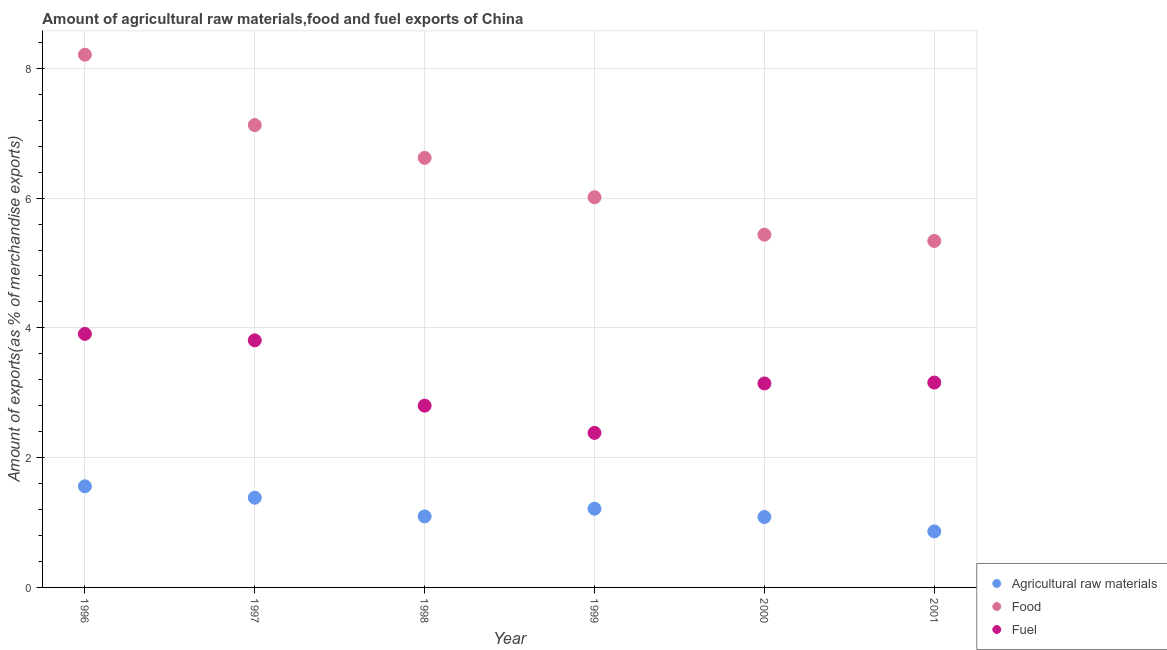What is the percentage of food exports in 2001?
Ensure brevity in your answer.  5.34. Across all years, what is the maximum percentage of fuel exports?
Ensure brevity in your answer.  3.91. Across all years, what is the minimum percentage of fuel exports?
Keep it short and to the point. 2.38. In which year was the percentage of food exports maximum?
Make the answer very short. 1996. In which year was the percentage of raw materials exports minimum?
Provide a succinct answer. 2001. What is the total percentage of fuel exports in the graph?
Give a very brief answer. 19.2. What is the difference between the percentage of food exports in 1997 and that in 2000?
Make the answer very short. 1.69. What is the difference between the percentage of raw materials exports in 1997 and the percentage of food exports in 1998?
Ensure brevity in your answer.  -5.24. What is the average percentage of fuel exports per year?
Your answer should be very brief. 3.2. In the year 1997, what is the difference between the percentage of raw materials exports and percentage of food exports?
Provide a short and direct response. -5.74. In how many years, is the percentage of food exports greater than 3.6 %?
Your answer should be very brief. 6. What is the ratio of the percentage of fuel exports in 1998 to that in 1999?
Offer a very short reply. 1.18. Is the percentage of food exports in 1997 less than that in 1998?
Provide a short and direct response. No. What is the difference between the highest and the second highest percentage of food exports?
Your answer should be compact. 1.09. What is the difference between the highest and the lowest percentage of food exports?
Ensure brevity in your answer.  2.87. In how many years, is the percentage of raw materials exports greater than the average percentage of raw materials exports taken over all years?
Give a very brief answer. 3. Is the percentage of raw materials exports strictly greater than the percentage of fuel exports over the years?
Make the answer very short. No. How many dotlines are there?
Offer a terse response. 3. What is the difference between two consecutive major ticks on the Y-axis?
Ensure brevity in your answer.  2. Does the graph contain grids?
Keep it short and to the point. Yes. Where does the legend appear in the graph?
Give a very brief answer. Bottom right. What is the title of the graph?
Make the answer very short. Amount of agricultural raw materials,food and fuel exports of China. What is the label or title of the X-axis?
Keep it short and to the point. Year. What is the label or title of the Y-axis?
Your response must be concise. Amount of exports(as % of merchandise exports). What is the Amount of exports(as % of merchandise exports) in Agricultural raw materials in 1996?
Give a very brief answer. 1.56. What is the Amount of exports(as % of merchandise exports) of Food in 1996?
Provide a succinct answer. 8.21. What is the Amount of exports(as % of merchandise exports) of Fuel in 1996?
Offer a terse response. 3.91. What is the Amount of exports(as % of merchandise exports) in Agricultural raw materials in 1997?
Provide a succinct answer. 1.38. What is the Amount of exports(as % of merchandise exports) of Food in 1997?
Give a very brief answer. 7.13. What is the Amount of exports(as % of merchandise exports) of Fuel in 1997?
Your response must be concise. 3.81. What is the Amount of exports(as % of merchandise exports) in Agricultural raw materials in 1998?
Make the answer very short. 1.09. What is the Amount of exports(as % of merchandise exports) in Food in 1998?
Offer a very short reply. 6.62. What is the Amount of exports(as % of merchandise exports) in Fuel in 1998?
Provide a short and direct response. 2.8. What is the Amount of exports(as % of merchandise exports) in Agricultural raw materials in 1999?
Make the answer very short. 1.21. What is the Amount of exports(as % of merchandise exports) in Food in 1999?
Give a very brief answer. 6.01. What is the Amount of exports(as % of merchandise exports) in Fuel in 1999?
Offer a very short reply. 2.38. What is the Amount of exports(as % of merchandise exports) of Agricultural raw materials in 2000?
Provide a succinct answer. 1.09. What is the Amount of exports(as % of merchandise exports) in Food in 2000?
Give a very brief answer. 5.44. What is the Amount of exports(as % of merchandise exports) of Fuel in 2000?
Provide a succinct answer. 3.14. What is the Amount of exports(as % of merchandise exports) in Agricultural raw materials in 2001?
Your answer should be compact. 0.86. What is the Amount of exports(as % of merchandise exports) in Food in 2001?
Your response must be concise. 5.34. What is the Amount of exports(as % of merchandise exports) in Fuel in 2001?
Make the answer very short. 3.16. Across all years, what is the maximum Amount of exports(as % of merchandise exports) of Agricultural raw materials?
Your answer should be very brief. 1.56. Across all years, what is the maximum Amount of exports(as % of merchandise exports) of Food?
Make the answer very short. 8.21. Across all years, what is the maximum Amount of exports(as % of merchandise exports) of Fuel?
Provide a short and direct response. 3.91. Across all years, what is the minimum Amount of exports(as % of merchandise exports) in Agricultural raw materials?
Ensure brevity in your answer.  0.86. Across all years, what is the minimum Amount of exports(as % of merchandise exports) in Food?
Provide a short and direct response. 5.34. Across all years, what is the minimum Amount of exports(as % of merchandise exports) of Fuel?
Keep it short and to the point. 2.38. What is the total Amount of exports(as % of merchandise exports) of Agricultural raw materials in the graph?
Offer a terse response. 7.2. What is the total Amount of exports(as % of merchandise exports) in Food in the graph?
Make the answer very short. 38.75. What is the total Amount of exports(as % of merchandise exports) of Fuel in the graph?
Give a very brief answer. 19.2. What is the difference between the Amount of exports(as % of merchandise exports) in Agricultural raw materials in 1996 and that in 1997?
Provide a succinct answer. 0.18. What is the difference between the Amount of exports(as % of merchandise exports) of Food in 1996 and that in 1997?
Your response must be concise. 1.09. What is the difference between the Amount of exports(as % of merchandise exports) in Fuel in 1996 and that in 1997?
Your answer should be very brief. 0.1. What is the difference between the Amount of exports(as % of merchandise exports) in Agricultural raw materials in 1996 and that in 1998?
Your answer should be compact. 0.46. What is the difference between the Amount of exports(as % of merchandise exports) of Food in 1996 and that in 1998?
Offer a very short reply. 1.59. What is the difference between the Amount of exports(as % of merchandise exports) of Fuel in 1996 and that in 1998?
Provide a short and direct response. 1.11. What is the difference between the Amount of exports(as % of merchandise exports) of Agricultural raw materials in 1996 and that in 1999?
Your response must be concise. 0.35. What is the difference between the Amount of exports(as % of merchandise exports) of Food in 1996 and that in 1999?
Your answer should be very brief. 2.2. What is the difference between the Amount of exports(as % of merchandise exports) in Fuel in 1996 and that in 1999?
Give a very brief answer. 1.53. What is the difference between the Amount of exports(as % of merchandise exports) in Agricultural raw materials in 1996 and that in 2000?
Offer a terse response. 0.47. What is the difference between the Amount of exports(as % of merchandise exports) in Food in 1996 and that in 2000?
Provide a short and direct response. 2.77. What is the difference between the Amount of exports(as % of merchandise exports) in Fuel in 1996 and that in 2000?
Make the answer very short. 0.76. What is the difference between the Amount of exports(as % of merchandise exports) of Agricultural raw materials in 1996 and that in 2001?
Keep it short and to the point. 0.69. What is the difference between the Amount of exports(as % of merchandise exports) of Food in 1996 and that in 2001?
Your answer should be compact. 2.87. What is the difference between the Amount of exports(as % of merchandise exports) of Fuel in 1996 and that in 2001?
Ensure brevity in your answer.  0.75. What is the difference between the Amount of exports(as % of merchandise exports) of Agricultural raw materials in 1997 and that in 1998?
Offer a terse response. 0.29. What is the difference between the Amount of exports(as % of merchandise exports) in Food in 1997 and that in 1998?
Give a very brief answer. 0.51. What is the difference between the Amount of exports(as % of merchandise exports) of Fuel in 1997 and that in 1998?
Ensure brevity in your answer.  1.01. What is the difference between the Amount of exports(as % of merchandise exports) in Agricultural raw materials in 1997 and that in 1999?
Offer a very short reply. 0.17. What is the difference between the Amount of exports(as % of merchandise exports) of Food in 1997 and that in 1999?
Keep it short and to the point. 1.11. What is the difference between the Amount of exports(as % of merchandise exports) of Fuel in 1997 and that in 1999?
Your answer should be very brief. 1.43. What is the difference between the Amount of exports(as % of merchandise exports) of Agricultural raw materials in 1997 and that in 2000?
Offer a very short reply. 0.3. What is the difference between the Amount of exports(as % of merchandise exports) in Food in 1997 and that in 2000?
Give a very brief answer. 1.69. What is the difference between the Amount of exports(as % of merchandise exports) in Fuel in 1997 and that in 2000?
Offer a terse response. 0.66. What is the difference between the Amount of exports(as % of merchandise exports) in Agricultural raw materials in 1997 and that in 2001?
Offer a very short reply. 0.52. What is the difference between the Amount of exports(as % of merchandise exports) in Food in 1997 and that in 2001?
Provide a succinct answer. 1.79. What is the difference between the Amount of exports(as % of merchandise exports) of Fuel in 1997 and that in 2001?
Provide a short and direct response. 0.65. What is the difference between the Amount of exports(as % of merchandise exports) of Agricultural raw materials in 1998 and that in 1999?
Offer a terse response. -0.12. What is the difference between the Amount of exports(as % of merchandise exports) of Food in 1998 and that in 1999?
Your answer should be compact. 0.61. What is the difference between the Amount of exports(as % of merchandise exports) of Fuel in 1998 and that in 1999?
Offer a terse response. 0.42. What is the difference between the Amount of exports(as % of merchandise exports) of Agricultural raw materials in 1998 and that in 2000?
Your response must be concise. 0.01. What is the difference between the Amount of exports(as % of merchandise exports) of Food in 1998 and that in 2000?
Your answer should be very brief. 1.18. What is the difference between the Amount of exports(as % of merchandise exports) of Fuel in 1998 and that in 2000?
Offer a very short reply. -0.34. What is the difference between the Amount of exports(as % of merchandise exports) in Agricultural raw materials in 1998 and that in 2001?
Make the answer very short. 0.23. What is the difference between the Amount of exports(as % of merchandise exports) in Food in 1998 and that in 2001?
Make the answer very short. 1.28. What is the difference between the Amount of exports(as % of merchandise exports) in Fuel in 1998 and that in 2001?
Ensure brevity in your answer.  -0.36. What is the difference between the Amount of exports(as % of merchandise exports) of Agricultural raw materials in 1999 and that in 2000?
Your response must be concise. 0.13. What is the difference between the Amount of exports(as % of merchandise exports) of Food in 1999 and that in 2000?
Your answer should be very brief. 0.58. What is the difference between the Amount of exports(as % of merchandise exports) of Fuel in 1999 and that in 2000?
Your response must be concise. -0.76. What is the difference between the Amount of exports(as % of merchandise exports) of Agricultural raw materials in 1999 and that in 2001?
Give a very brief answer. 0.35. What is the difference between the Amount of exports(as % of merchandise exports) in Food in 1999 and that in 2001?
Provide a short and direct response. 0.67. What is the difference between the Amount of exports(as % of merchandise exports) of Fuel in 1999 and that in 2001?
Your answer should be compact. -0.78. What is the difference between the Amount of exports(as % of merchandise exports) in Agricultural raw materials in 2000 and that in 2001?
Ensure brevity in your answer.  0.22. What is the difference between the Amount of exports(as % of merchandise exports) of Food in 2000 and that in 2001?
Ensure brevity in your answer.  0.1. What is the difference between the Amount of exports(as % of merchandise exports) in Fuel in 2000 and that in 2001?
Your answer should be very brief. -0.01. What is the difference between the Amount of exports(as % of merchandise exports) of Agricultural raw materials in 1996 and the Amount of exports(as % of merchandise exports) of Food in 1997?
Offer a terse response. -5.57. What is the difference between the Amount of exports(as % of merchandise exports) of Agricultural raw materials in 1996 and the Amount of exports(as % of merchandise exports) of Fuel in 1997?
Offer a very short reply. -2.25. What is the difference between the Amount of exports(as % of merchandise exports) in Food in 1996 and the Amount of exports(as % of merchandise exports) in Fuel in 1997?
Your response must be concise. 4.4. What is the difference between the Amount of exports(as % of merchandise exports) in Agricultural raw materials in 1996 and the Amount of exports(as % of merchandise exports) in Food in 1998?
Your answer should be very brief. -5.06. What is the difference between the Amount of exports(as % of merchandise exports) of Agricultural raw materials in 1996 and the Amount of exports(as % of merchandise exports) of Fuel in 1998?
Keep it short and to the point. -1.24. What is the difference between the Amount of exports(as % of merchandise exports) in Food in 1996 and the Amount of exports(as % of merchandise exports) in Fuel in 1998?
Ensure brevity in your answer.  5.41. What is the difference between the Amount of exports(as % of merchandise exports) in Agricultural raw materials in 1996 and the Amount of exports(as % of merchandise exports) in Food in 1999?
Your response must be concise. -4.46. What is the difference between the Amount of exports(as % of merchandise exports) of Agricultural raw materials in 1996 and the Amount of exports(as % of merchandise exports) of Fuel in 1999?
Keep it short and to the point. -0.82. What is the difference between the Amount of exports(as % of merchandise exports) in Food in 1996 and the Amount of exports(as % of merchandise exports) in Fuel in 1999?
Offer a terse response. 5.83. What is the difference between the Amount of exports(as % of merchandise exports) of Agricultural raw materials in 1996 and the Amount of exports(as % of merchandise exports) of Food in 2000?
Your response must be concise. -3.88. What is the difference between the Amount of exports(as % of merchandise exports) in Agricultural raw materials in 1996 and the Amount of exports(as % of merchandise exports) in Fuel in 2000?
Make the answer very short. -1.58. What is the difference between the Amount of exports(as % of merchandise exports) of Food in 1996 and the Amount of exports(as % of merchandise exports) of Fuel in 2000?
Ensure brevity in your answer.  5.07. What is the difference between the Amount of exports(as % of merchandise exports) of Agricultural raw materials in 1996 and the Amount of exports(as % of merchandise exports) of Food in 2001?
Make the answer very short. -3.78. What is the difference between the Amount of exports(as % of merchandise exports) of Agricultural raw materials in 1996 and the Amount of exports(as % of merchandise exports) of Fuel in 2001?
Ensure brevity in your answer.  -1.6. What is the difference between the Amount of exports(as % of merchandise exports) in Food in 1996 and the Amount of exports(as % of merchandise exports) in Fuel in 2001?
Give a very brief answer. 5.05. What is the difference between the Amount of exports(as % of merchandise exports) of Agricultural raw materials in 1997 and the Amount of exports(as % of merchandise exports) of Food in 1998?
Keep it short and to the point. -5.24. What is the difference between the Amount of exports(as % of merchandise exports) of Agricultural raw materials in 1997 and the Amount of exports(as % of merchandise exports) of Fuel in 1998?
Your answer should be very brief. -1.42. What is the difference between the Amount of exports(as % of merchandise exports) in Food in 1997 and the Amount of exports(as % of merchandise exports) in Fuel in 1998?
Ensure brevity in your answer.  4.32. What is the difference between the Amount of exports(as % of merchandise exports) in Agricultural raw materials in 1997 and the Amount of exports(as % of merchandise exports) in Food in 1999?
Your answer should be compact. -4.63. What is the difference between the Amount of exports(as % of merchandise exports) in Agricultural raw materials in 1997 and the Amount of exports(as % of merchandise exports) in Fuel in 1999?
Offer a terse response. -1. What is the difference between the Amount of exports(as % of merchandise exports) in Food in 1997 and the Amount of exports(as % of merchandise exports) in Fuel in 1999?
Offer a terse response. 4.74. What is the difference between the Amount of exports(as % of merchandise exports) in Agricultural raw materials in 1997 and the Amount of exports(as % of merchandise exports) in Food in 2000?
Keep it short and to the point. -4.05. What is the difference between the Amount of exports(as % of merchandise exports) in Agricultural raw materials in 1997 and the Amount of exports(as % of merchandise exports) in Fuel in 2000?
Offer a terse response. -1.76. What is the difference between the Amount of exports(as % of merchandise exports) in Food in 1997 and the Amount of exports(as % of merchandise exports) in Fuel in 2000?
Keep it short and to the point. 3.98. What is the difference between the Amount of exports(as % of merchandise exports) of Agricultural raw materials in 1997 and the Amount of exports(as % of merchandise exports) of Food in 2001?
Make the answer very short. -3.96. What is the difference between the Amount of exports(as % of merchandise exports) in Agricultural raw materials in 1997 and the Amount of exports(as % of merchandise exports) in Fuel in 2001?
Ensure brevity in your answer.  -1.77. What is the difference between the Amount of exports(as % of merchandise exports) of Food in 1997 and the Amount of exports(as % of merchandise exports) of Fuel in 2001?
Provide a short and direct response. 3.97. What is the difference between the Amount of exports(as % of merchandise exports) of Agricultural raw materials in 1998 and the Amount of exports(as % of merchandise exports) of Food in 1999?
Provide a short and direct response. -4.92. What is the difference between the Amount of exports(as % of merchandise exports) in Agricultural raw materials in 1998 and the Amount of exports(as % of merchandise exports) in Fuel in 1999?
Your response must be concise. -1.29. What is the difference between the Amount of exports(as % of merchandise exports) in Food in 1998 and the Amount of exports(as % of merchandise exports) in Fuel in 1999?
Ensure brevity in your answer.  4.24. What is the difference between the Amount of exports(as % of merchandise exports) in Agricultural raw materials in 1998 and the Amount of exports(as % of merchandise exports) in Food in 2000?
Your answer should be compact. -4.34. What is the difference between the Amount of exports(as % of merchandise exports) of Agricultural raw materials in 1998 and the Amount of exports(as % of merchandise exports) of Fuel in 2000?
Keep it short and to the point. -2.05. What is the difference between the Amount of exports(as % of merchandise exports) of Food in 1998 and the Amount of exports(as % of merchandise exports) of Fuel in 2000?
Your answer should be very brief. 3.48. What is the difference between the Amount of exports(as % of merchandise exports) in Agricultural raw materials in 1998 and the Amount of exports(as % of merchandise exports) in Food in 2001?
Give a very brief answer. -4.25. What is the difference between the Amount of exports(as % of merchandise exports) in Agricultural raw materials in 1998 and the Amount of exports(as % of merchandise exports) in Fuel in 2001?
Make the answer very short. -2.06. What is the difference between the Amount of exports(as % of merchandise exports) in Food in 1998 and the Amount of exports(as % of merchandise exports) in Fuel in 2001?
Offer a very short reply. 3.46. What is the difference between the Amount of exports(as % of merchandise exports) of Agricultural raw materials in 1999 and the Amount of exports(as % of merchandise exports) of Food in 2000?
Make the answer very short. -4.22. What is the difference between the Amount of exports(as % of merchandise exports) in Agricultural raw materials in 1999 and the Amount of exports(as % of merchandise exports) in Fuel in 2000?
Make the answer very short. -1.93. What is the difference between the Amount of exports(as % of merchandise exports) of Food in 1999 and the Amount of exports(as % of merchandise exports) of Fuel in 2000?
Your answer should be very brief. 2.87. What is the difference between the Amount of exports(as % of merchandise exports) in Agricultural raw materials in 1999 and the Amount of exports(as % of merchandise exports) in Food in 2001?
Keep it short and to the point. -4.13. What is the difference between the Amount of exports(as % of merchandise exports) in Agricultural raw materials in 1999 and the Amount of exports(as % of merchandise exports) in Fuel in 2001?
Ensure brevity in your answer.  -1.94. What is the difference between the Amount of exports(as % of merchandise exports) in Food in 1999 and the Amount of exports(as % of merchandise exports) in Fuel in 2001?
Your answer should be compact. 2.86. What is the difference between the Amount of exports(as % of merchandise exports) of Agricultural raw materials in 2000 and the Amount of exports(as % of merchandise exports) of Food in 2001?
Your response must be concise. -4.25. What is the difference between the Amount of exports(as % of merchandise exports) in Agricultural raw materials in 2000 and the Amount of exports(as % of merchandise exports) in Fuel in 2001?
Ensure brevity in your answer.  -2.07. What is the difference between the Amount of exports(as % of merchandise exports) of Food in 2000 and the Amount of exports(as % of merchandise exports) of Fuel in 2001?
Offer a terse response. 2.28. What is the average Amount of exports(as % of merchandise exports) in Agricultural raw materials per year?
Provide a succinct answer. 1.2. What is the average Amount of exports(as % of merchandise exports) in Food per year?
Your answer should be compact. 6.46. What is the average Amount of exports(as % of merchandise exports) in Fuel per year?
Give a very brief answer. 3.2. In the year 1996, what is the difference between the Amount of exports(as % of merchandise exports) of Agricultural raw materials and Amount of exports(as % of merchandise exports) of Food?
Provide a short and direct response. -6.65. In the year 1996, what is the difference between the Amount of exports(as % of merchandise exports) in Agricultural raw materials and Amount of exports(as % of merchandise exports) in Fuel?
Offer a terse response. -2.35. In the year 1996, what is the difference between the Amount of exports(as % of merchandise exports) in Food and Amount of exports(as % of merchandise exports) in Fuel?
Provide a succinct answer. 4.3. In the year 1997, what is the difference between the Amount of exports(as % of merchandise exports) of Agricultural raw materials and Amount of exports(as % of merchandise exports) of Food?
Provide a short and direct response. -5.74. In the year 1997, what is the difference between the Amount of exports(as % of merchandise exports) of Agricultural raw materials and Amount of exports(as % of merchandise exports) of Fuel?
Provide a succinct answer. -2.43. In the year 1997, what is the difference between the Amount of exports(as % of merchandise exports) in Food and Amount of exports(as % of merchandise exports) in Fuel?
Your response must be concise. 3.32. In the year 1998, what is the difference between the Amount of exports(as % of merchandise exports) of Agricultural raw materials and Amount of exports(as % of merchandise exports) of Food?
Offer a terse response. -5.53. In the year 1998, what is the difference between the Amount of exports(as % of merchandise exports) of Agricultural raw materials and Amount of exports(as % of merchandise exports) of Fuel?
Offer a terse response. -1.71. In the year 1998, what is the difference between the Amount of exports(as % of merchandise exports) of Food and Amount of exports(as % of merchandise exports) of Fuel?
Make the answer very short. 3.82. In the year 1999, what is the difference between the Amount of exports(as % of merchandise exports) in Agricultural raw materials and Amount of exports(as % of merchandise exports) in Food?
Ensure brevity in your answer.  -4.8. In the year 1999, what is the difference between the Amount of exports(as % of merchandise exports) in Agricultural raw materials and Amount of exports(as % of merchandise exports) in Fuel?
Provide a short and direct response. -1.17. In the year 1999, what is the difference between the Amount of exports(as % of merchandise exports) of Food and Amount of exports(as % of merchandise exports) of Fuel?
Provide a short and direct response. 3.63. In the year 2000, what is the difference between the Amount of exports(as % of merchandise exports) of Agricultural raw materials and Amount of exports(as % of merchandise exports) of Food?
Offer a very short reply. -4.35. In the year 2000, what is the difference between the Amount of exports(as % of merchandise exports) in Agricultural raw materials and Amount of exports(as % of merchandise exports) in Fuel?
Your answer should be compact. -2.06. In the year 2000, what is the difference between the Amount of exports(as % of merchandise exports) of Food and Amount of exports(as % of merchandise exports) of Fuel?
Make the answer very short. 2.29. In the year 2001, what is the difference between the Amount of exports(as % of merchandise exports) of Agricultural raw materials and Amount of exports(as % of merchandise exports) of Food?
Your answer should be very brief. -4.48. In the year 2001, what is the difference between the Amount of exports(as % of merchandise exports) of Agricultural raw materials and Amount of exports(as % of merchandise exports) of Fuel?
Give a very brief answer. -2.29. In the year 2001, what is the difference between the Amount of exports(as % of merchandise exports) of Food and Amount of exports(as % of merchandise exports) of Fuel?
Make the answer very short. 2.18. What is the ratio of the Amount of exports(as % of merchandise exports) of Agricultural raw materials in 1996 to that in 1997?
Offer a very short reply. 1.13. What is the ratio of the Amount of exports(as % of merchandise exports) of Food in 1996 to that in 1997?
Your answer should be compact. 1.15. What is the ratio of the Amount of exports(as % of merchandise exports) in Fuel in 1996 to that in 1997?
Keep it short and to the point. 1.03. What is the ratio of the Amount of exports(as % of merchandise exports) in Agricultural raw materials in 1996 to that in 1998?
Offer a terse response. 1.42. What is the ratio of the Amount of exports(as % of merchandise exports) of Food in 1996 to that in 1998?
Provide a succinct answer. 1.24. What is the ratio of the Amount of exports(as % of merchandise exports) in Fuel in 1996 to that in 1998?
Your answer should be compact. 1.39. What is the ratio of the Amount of exports(as % of merchandise exports) in Agricultural raw materials in 1996 to that in 1999?
Keep it short and to the point. 1.29. What is the ratio of the Amount of exports(as % of merchandise exports) in Food in 1996 to that in 1999?
Make the answer very short. 1.37. What is the ratio of the Amount of exports(as % of merchandise exports) in Fuel in 1996 to that in 1999?
Your response must be concise. 1.64. What is the ratio of the Amount of exports(as % of merchandise exports) of Agricultural raw materials in 1996 to that in 2000?
Keep it short and to the point. 1.44. What is the ratio of the Amount of exports(as % of merchandise exports) in Food in 1996 to that in 2000?
Offer a terse response. 1.51. What is the ratio of the Amount of exports(as % of merchandise exports) in Fuel in 1996 to that in 2000?
Make the answer very short. 1.24. What is the ratio of the Amount of exports(as % of merchandise exports) in Agricultural raw materials in 1996 to that in 2001?
Ensure brevity in your answer.  1.8. What is the ratio of the Amount of exports(as % of merchandise exports) in Food in 1996 to that in 2001?
Give a very brief answer. 1.54. What is the ratio of the Amount of exports(as % of merchandise exports) in Fuel in 1996 to that in 2001?
Your response must be concise. 1.24. What is the ratio of the Amount of exports(as % of merchandise exports) of Agricultural raw materials in 1997 to that in 1998?
Offer a very short reply. 1.26. What is the ratio of the Amount of exports(as % of merchandise exports) in Food in 1997 to that in 1998?
Offer a terse response. 1.08. What is the ratio of the Amount of exports(as % of merchandise exports) in Fuel in 1997 to that in 1998?
Make the answer very short. 1.36. What is the ratio of the Amount of exports(as % of merchandise exports) in Agricultural raw materials in 1997 to that in 1999?
Provide a succinct answer. 1.14. What is the ratio of the Amount of exports(as % of merchandise exports) in Food in 1997 to that in 1999?
Provide a short and direct response. 1.19. What is the ratio of the Amount of exports(as % of merchandise exports) in Fuel in 1997 to that in 1999?
Your answer should be compact. 1.6. What is the ratio of the Amount of exports(as % of merchandise exports) in Agricultural raw materials in 1997 to that in 2000?
Keep it short and to the point. 1.27. What is the ratio of the Amount of exports(as % of merchandise exports) in Food in 1997 to that in 2000?
Provide a short and direct response. 1.31. What is the ratio of the Amount of exports(as % of merchandise exports) in Fuel in 1997 to that in 2000?
Provide a short and direct response. 1.21. What is the ratio of the Amount of exports(as % of merchandise exports) of Agricultural raw materials in 1997 to that in 2001?
Provide a short and direct response. 1.6. What is the ratio of the Amount of exports(as % of merchandise exports) in Food in 1997 to that in 2001?
Provide a short and direct response. 1.33. What is the ratio of the Amount of exports(as % of merchandise exports) in Fuel in 1997 to that in 2001?
Make the answer very short. 1.21. What is the ratio of the Amount of exports(as % of merchandise exports) in Agricultural raw materials in 1998 to that in 1999?
Make the answer very short. 0.9. What is the ratio of the Amount of exports(as % of merchandise exports) of Food in 1998 to that in 1999?
Ensure brevity in your answer.  1.1. What is the ratio of the Amount of exports(as % of merchandise exports) of Fuel in 1998 to that in 1999?
Offer a very short reply. 1.18. What is the ratio of the Amount of exports(as % of merchandise exports) of Agricultural raw materials in 1998 to that in 2000?
Keep it short and to the point. 1.01. What is the ratio of the Amount of exports(as % of merchandise exports) of Food in 1998 to that in 2000?
Provide a short and direct response. 1.22. What is the ratio of the Amount of exports(as % of merchandise exports) of Fuel in 1998 to that in 2000?
Keep it short and to the point. 0.89. What is the ratio of the Amount of exports(as % of merchandise exports) of Agricultural raw materials in 1998 to that in 2001?
Offer a very short reply. 1.27. What is the ratio of the Amount of exports(as % of merchandise exports) of Food in 1998 to that in 2001?
Keep it short and to the point. 1.24. What is the ratio of the Amount of exports(as % of merchandise exports) of Fuel in 1998 to that in 2001?
Your answer should be compact. 0.89. What is the ratio of the Amount of exports(as % of merchandise exports) of Agricultural raw materials in 1999 to that in 2000?
Offer a very short reply. 1.12. What is the ratio of the Amount of exports(as % of merchandise exports) of Food in 1999 to that in 2000?
Make the answer very short. 1.11. What is the ratio of the Amount of exports(as % of merchandise exports) in Fuel in 1999 to that in 2000?
Give a very brief answer. 0.76. What is the ratio of the Amount of exports(as % of merchandise exports) in Agricultural raw materials in 1999 to that in 2001?
Your answer should be very brief. 1.4. What is the ratio of the Amount of exports(as % of merchandise exports) of Food in 1999 to that in 2001?
Keep it short and to the point. 1.13. What is the ratio of the Amount of exports(as % of merchandise exports) of Fuel in 1999 to that in 2001?
Ensure brevity in your answer.  0.75. What is the ratio of the Amount of exports(as % of merchandise exports) of Agricultural raw materials in 2000 to that in 2001?
Provide a short and direct response. 1.26. What is the ratio of the Amount of exports(as % of merchandise exports) in Food in 2000 to that in 2001?
Keep it short and to the point. 1.02. What is the difference between the highest and the second highest Amount of exports(as % of merchandise exports) in Agricultural raw materials?
Keep it short and to the point. 0.18. What is the difference between the highest and the second highest Amount of exports(as % of merchandise exports) in Food?
Give a very brief answer. 1.09. What is the difference between the highest and the second highest Amount of exports(as % of merchandise exports) in Fuel?
Your response must be concise. 0.1. What is the difference between the highest and the lowest Amount of exports(as % of merchandise exports) in Agricultural raw materials?
Your response must be concise. 0.69. What is the difference between the highest and the lowest Amount of exports(as % of merchandise exports) of Food?
Offer a very short reply. 2.87. What is the difference between the highest and the lowest Amount of exports(as % of merchandise exports) in Fuel?
Offer a very short reply. 1.53. 